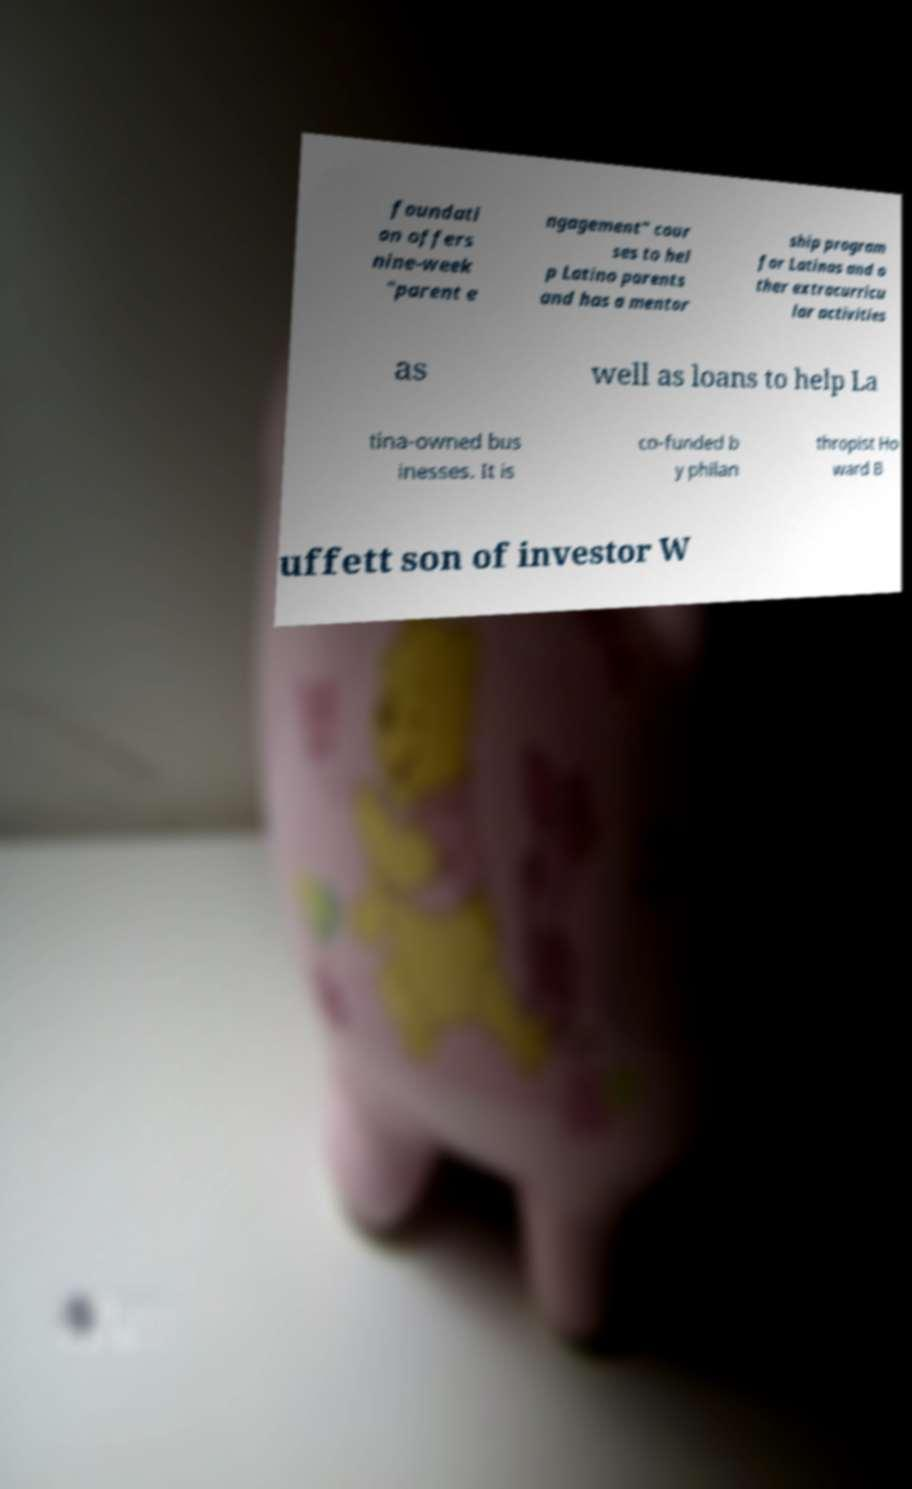There's text embedded in this image that I need extracted. Can you transcribe it verbatim? foundati on offers nine-week "parent e ngagement" cour ses to hel p Latino parents and has a mentor ship program for Latinas and o ther extracurricu lar activities as well as loans to help La tina-owned bus inesses. It is co-funded b y philan thropist Ho ward B uffett son of investor W 